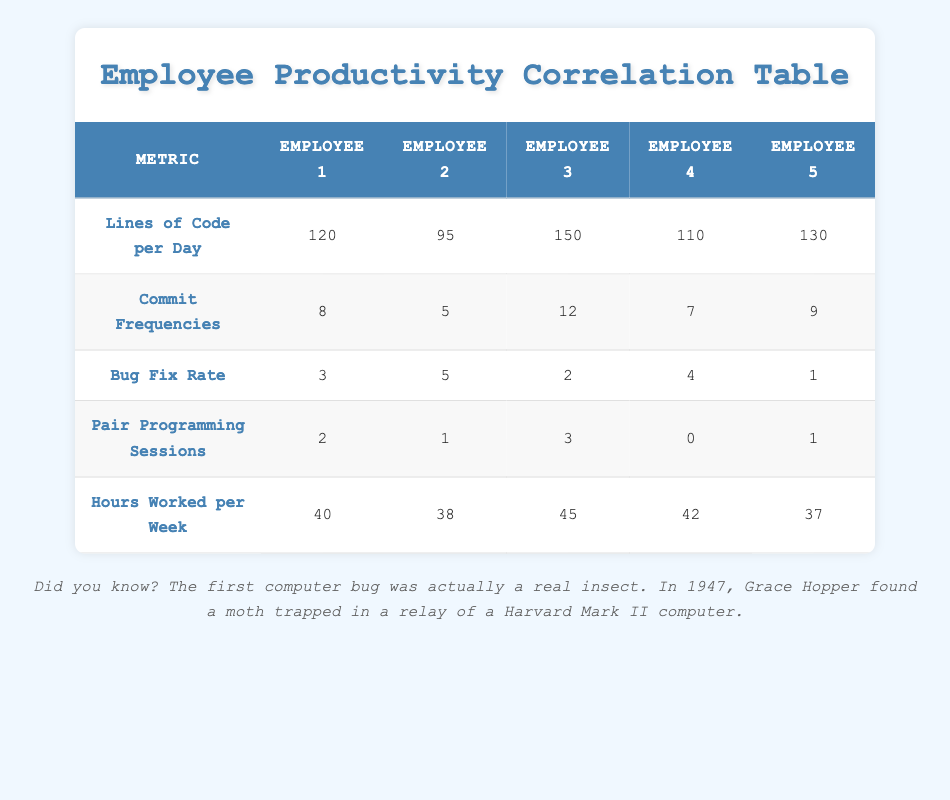What is the highest lines of code per day recorded among the employees? By reviewing the table, Employee 3 has the highest lines of code per day at 150.
Answer: 150 Which employee has the lowest bug fix rate? Looking at the bug fix rate row, Employee 5 has the lowest value of 1.
Answer: 1 What is the average number of pair programming sessions across all employees? Adding the pair programming sessions gives (2 + 1 + 3 + 0 + 1) = 7. There are 5 employees, so the average is 7/5 = 1.4.
Answer: 1.4 True or False: Employee 4 has a higher commit frequency than Employee 5. Comparing the commit frequencies, Employee 4 has 7 while Employee 5 has 9, so the statement is false.
Answer: False How many more hours did Employee 3 work per week compared to Employee 5? Employee 3 worked 45 hours and Employee 5 worked 37 hours. The difference is 45 - 37 = 8 hours.
Answer: 8 Which employee has the highest commit frequency and what is the value? Employee 3 has the highest commit frequency, which is 12.
Answer: 12 Is there any employee who worked fewer hours per week than Employee 2? Employee 2 worked 38 hours. Employee 5 worked 37 hours, which is fewer than 38, making the statement true.
Answer: Yes What is the total number of bug fixes made by all employees together? Summing the bug fix rates gives (3 + 5 + 2 + 4 + 1) = 15. Thus, total bug fixes are 15.
Answer: 15 Explain the relationship between hours worked per week and lines of code written per day for Employee 1 and Employee 4. Employee 1 worked 40 hours and wrote 120 lines, whereas Employee 4 worked 42 hours and wrote 110 lines. Employee 1 wrote more lines than Employee 4 despite working fewer hours, indicating potentially differing productivity levels.
Answer: Varies by employee 